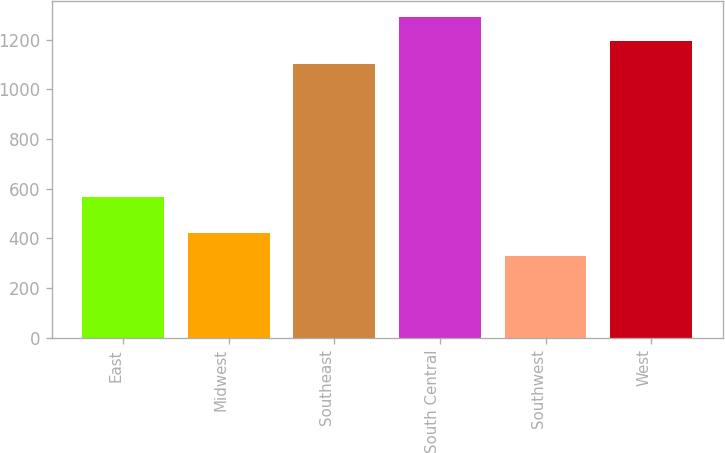Convert chart to OTSL. <chart><loc_0><loc_0><loc_500><loc_500><bar_chart><fcel>East<fcel>Midwest<fcel>Southeast<fcel>South Central<fcel>Southwest<fcel>West<nl><fcel>565.3<fcel>423.16<fcel>1101.9<fcel>1292.82<fcel>327.7<fcel>1197.36<nl></chart> 